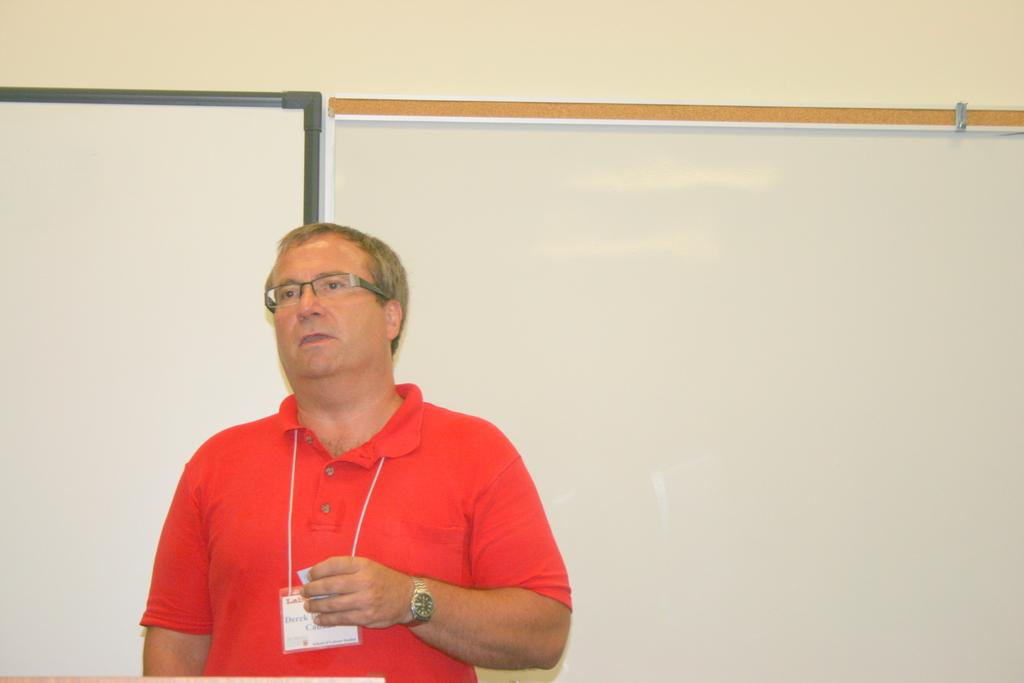What is the person in the image wearing? The person is wearing a red t-shirt. What is the person holding in the image? The person is standing and holding a paper. What can be seen on the wall in the background of the image? There are boards on the wall in the background. What is located at the bottom left of the image? There is a wooden object at the bottom left of the image. How many trees are visible in the image? There are no trees visible in the image. What type of cannon is present in the image? There is no cannon present in the image. 